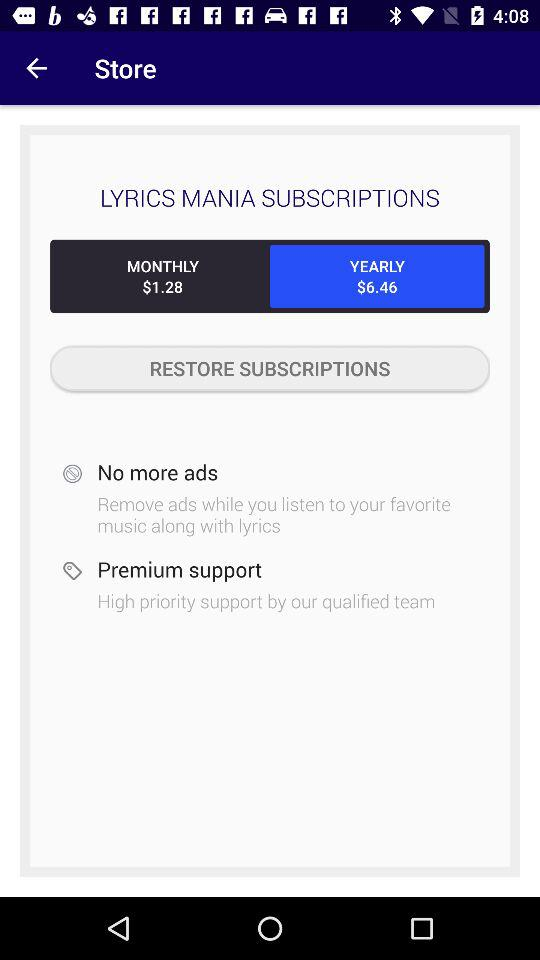How much more does the yearly subscription cost than the monthly subscription?
Answer the question using a single word or phrase. $5.18 